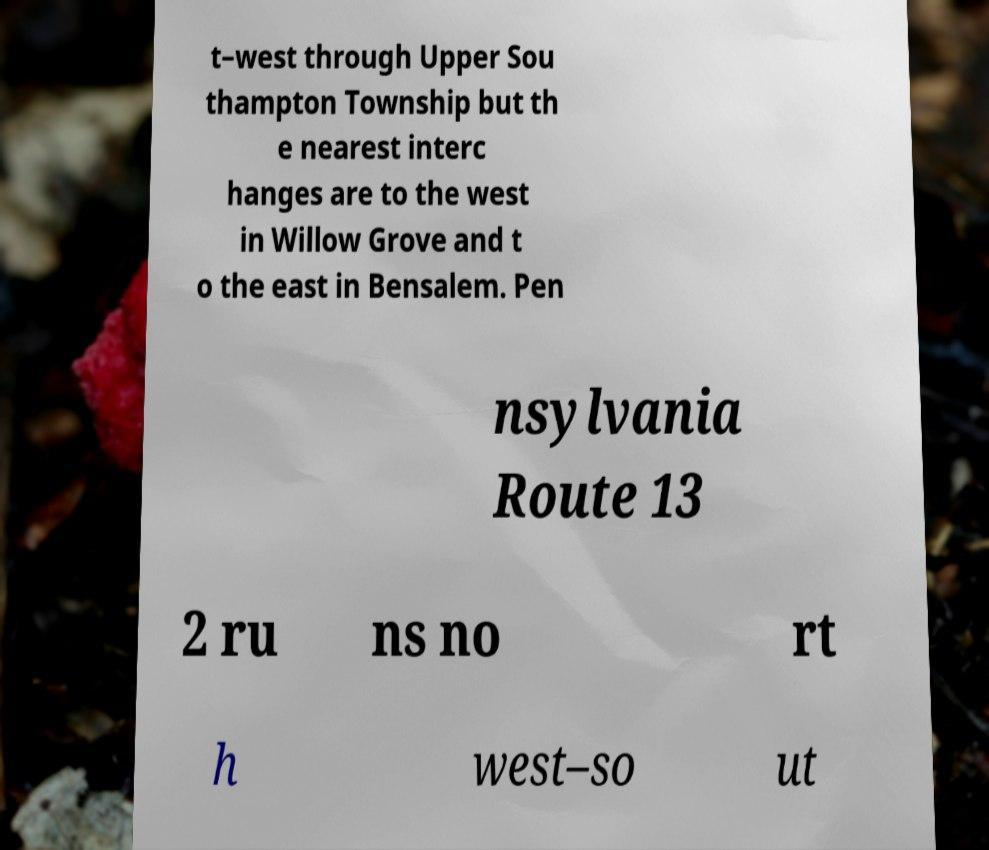Could you assist in decoding the text presented in this image and type it out clearly? t–west through Upper Sou thampton Township but th e nearest interc hanges are to the west in Willow Grove and t o the east in Bensalem. Pen nsylvania Route 13 2 ru ns no rt h west–so ut 